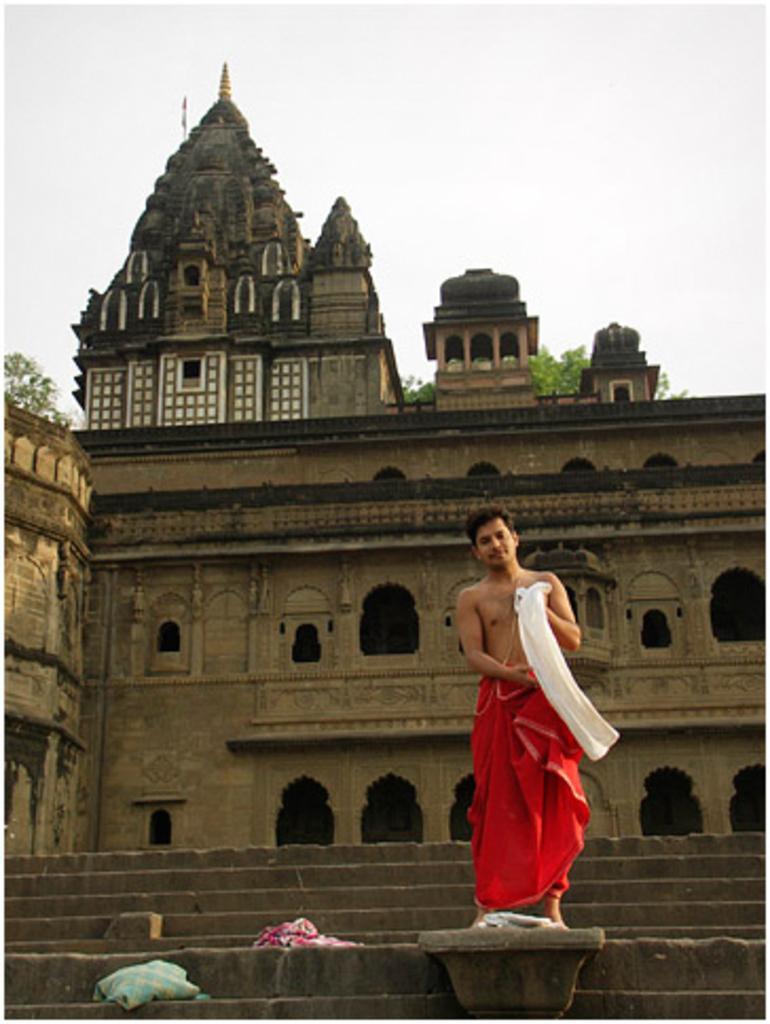Could you give a brief overview of what you see in this image? In this image we can see a person wearing red color lungi standing on the stairs and at the background of the image there is ancient temple and trees. 